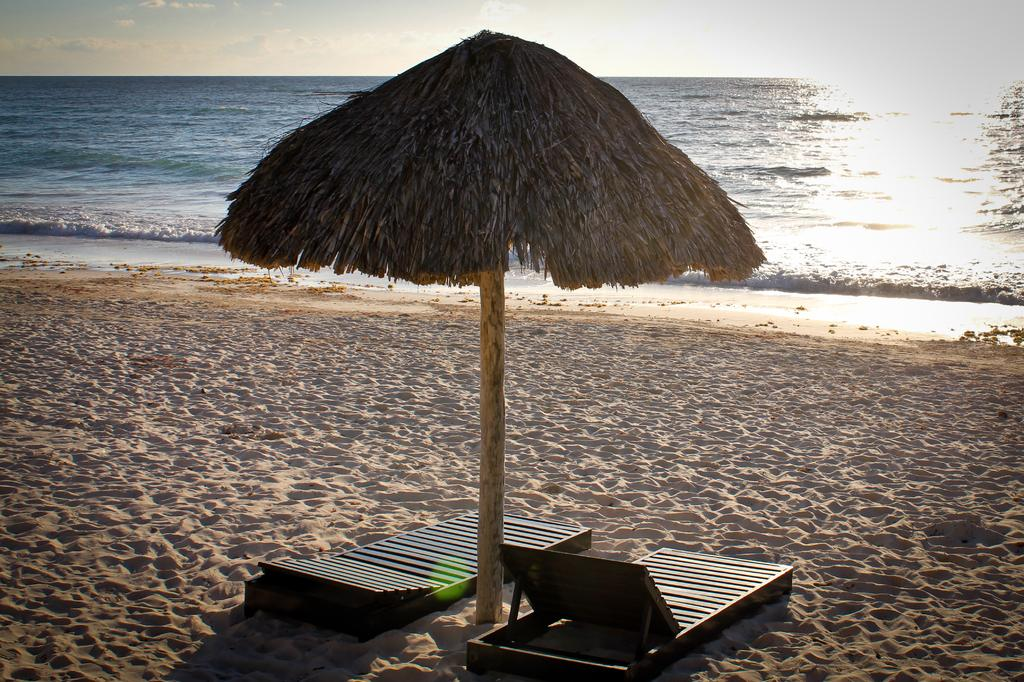What type of structure is in the image? There is a hut in the image. What objects are in the foreground of the image? There are chairs in the foreground of the image. What natural element is visible in the image? Water is visible in the image. What part of the sky can be seen in the image? The sky is visible in the image. What is present in the sky? There are clouds in the sky. What type of terrain is visible in the image? There is sand visible in the image. What type of drum can be heard playing in the image? There is no drum present in the image, so it is not possible to hear any drum playing. 